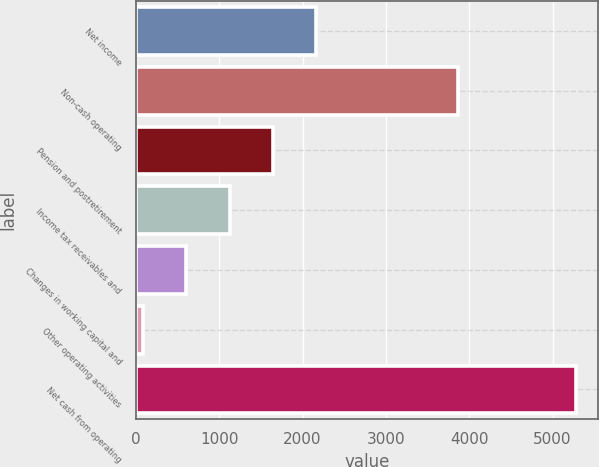<chart> <loc_0><loc_0><loc_500><loc_500><bar_chart><fcel>Net income<fcel>Non-cash operating<fcel>Pension and postretirement<fcel>Income tax receivables and<fcel>Changes in working capital and<fcel>Other operating activities<fcel>Net cash from operating<nl><fcel>2165.6<fcel>3863<fcel>1645.7<fcel>1125.8<fcel>605.9<fcel>86<fcel>5285<nl></chart> 